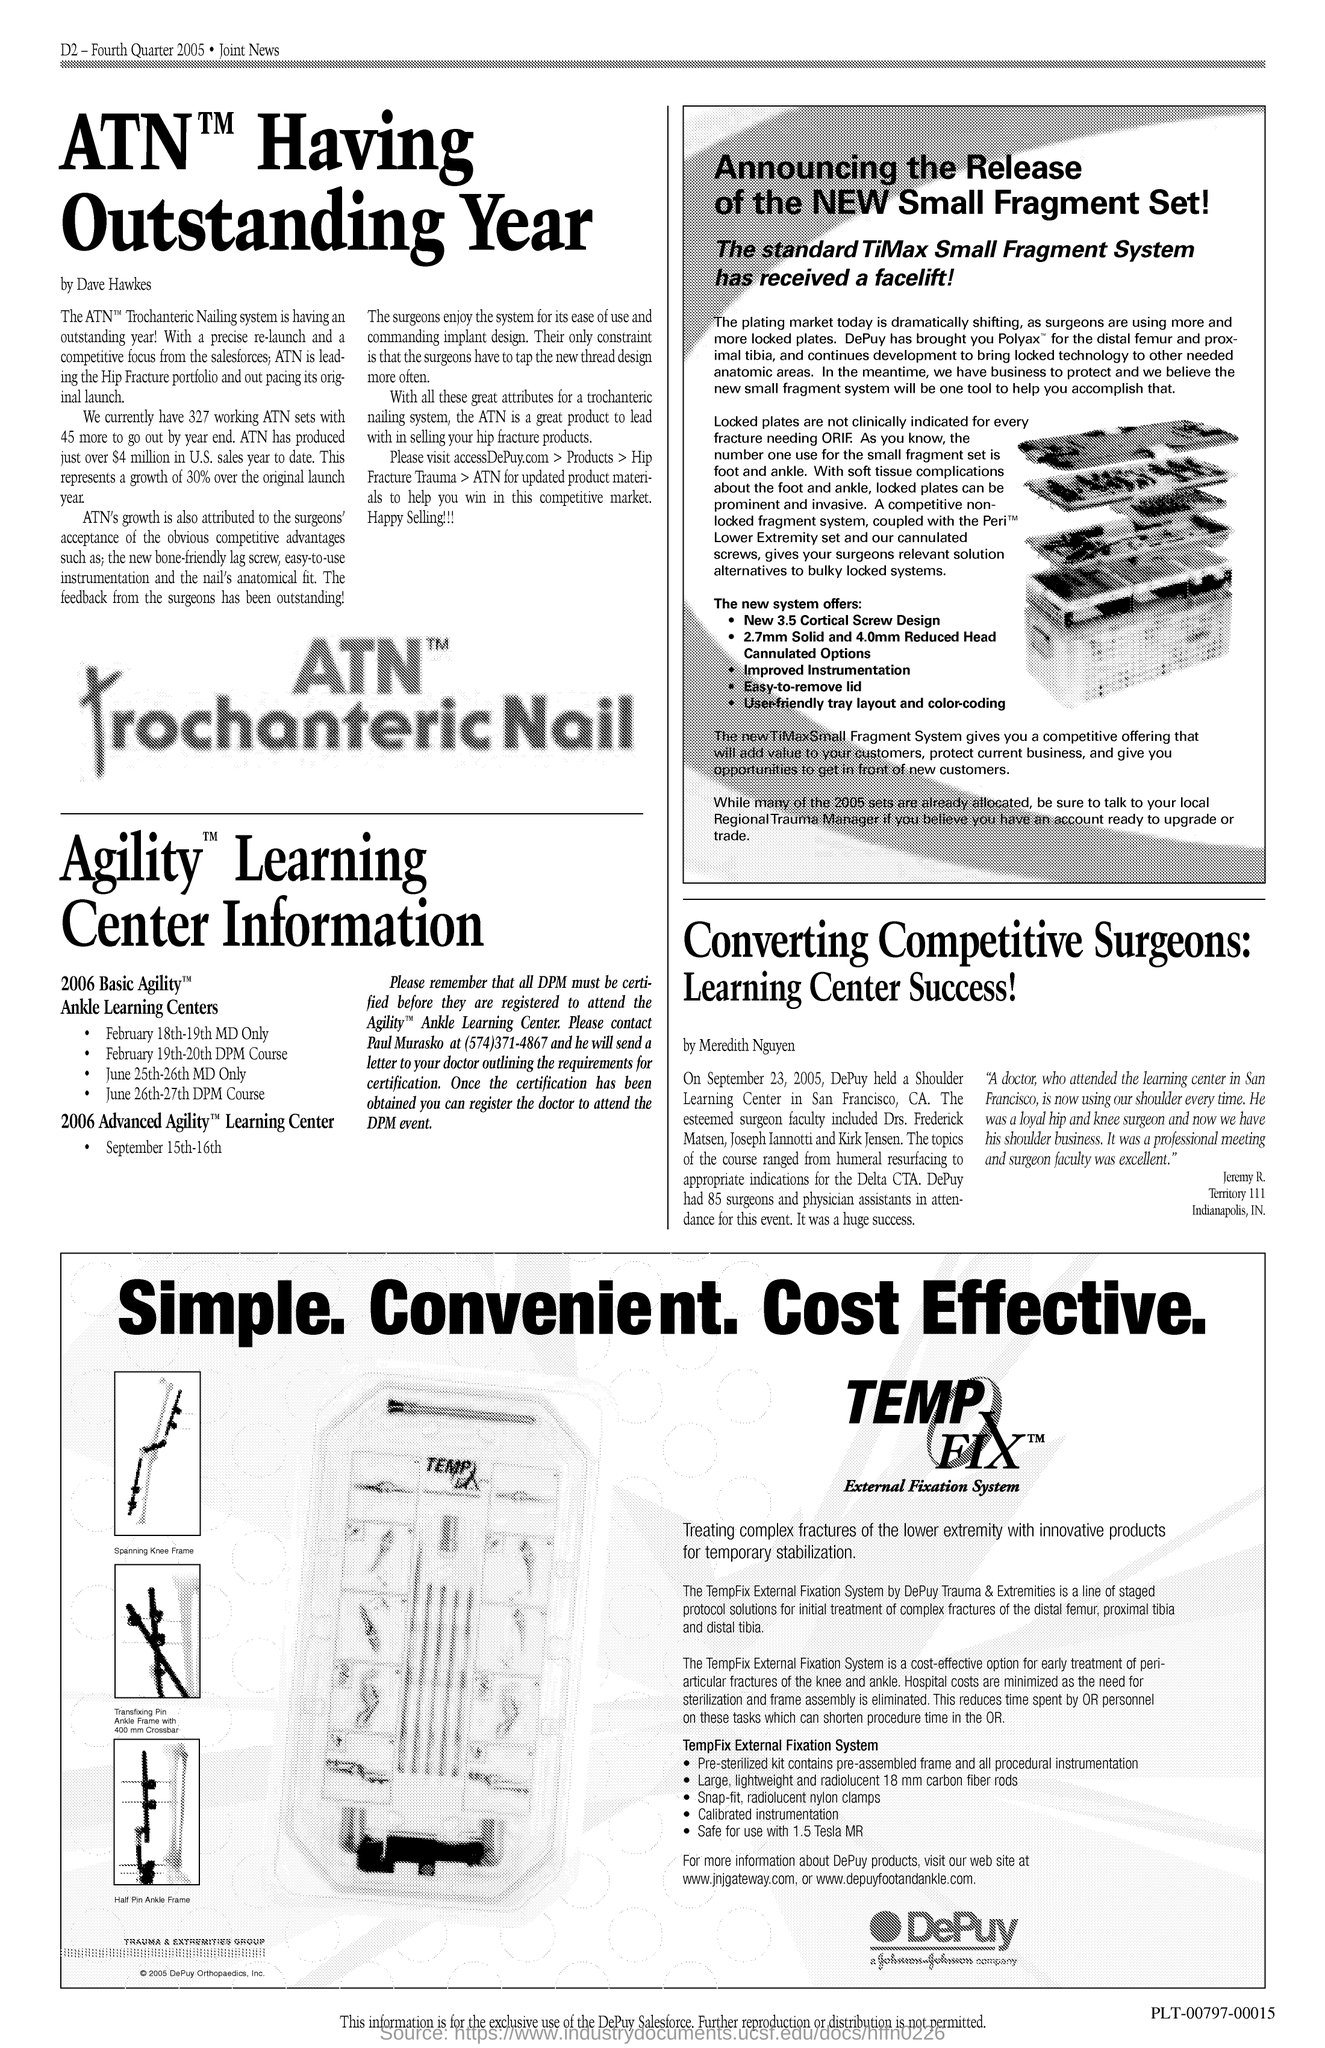Give some essential details in this illustration. ATN has experienced a growth rate of 30% since its original launch year. Dave Hawkes is the author of the article on ATN. The leadership of the Hip Fracture portfolio is currently being led by ATN. Surgeons enjoy the system due to its ease of use and superior implant design, making it a highly desirable tool in the field of robotic surgery. There are currently 327 ATN sets in existence. 